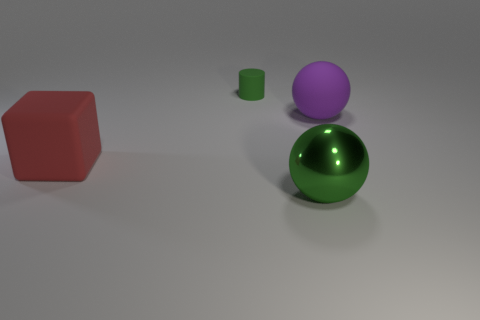How would you describe the lighting and shadows in the image? The lighting in the image is soft and diffused, coming from the top left, as suggested by the positioning of shadows. Each object casts a soft-edged, grey shadow on the ground, aiding in the perception of their spatial arrangement and volume. 